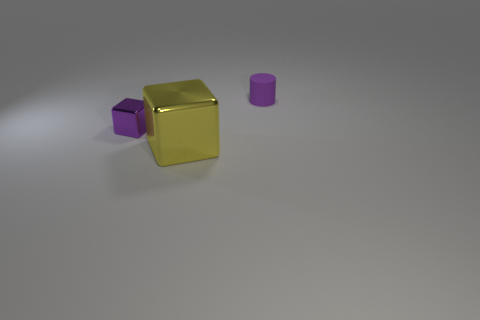Subtract all purple blocks. How many blocks are left? 1 Add 2 small purple shiny things. How many objects exist? 5 Subtract 1 cylinders. How many cylinders are left? 0 Subtract all cylinders. How many objects are left? 2 Subtract 0 green cylinders. How many objects are left? 3 Subtract all brown cubes. Subtract all gray cylinders. How many cubes are left? 2 Subtract all gray blocks. How many gray cylinders are left? 0 Subtract all purple things. Subtract all small yellow cylinders. How many objects are left? 1 Add 1 metallic things. How many metallic things are left? 3 Add 3 green metallic objects. How many green metallic objects exist? 3 